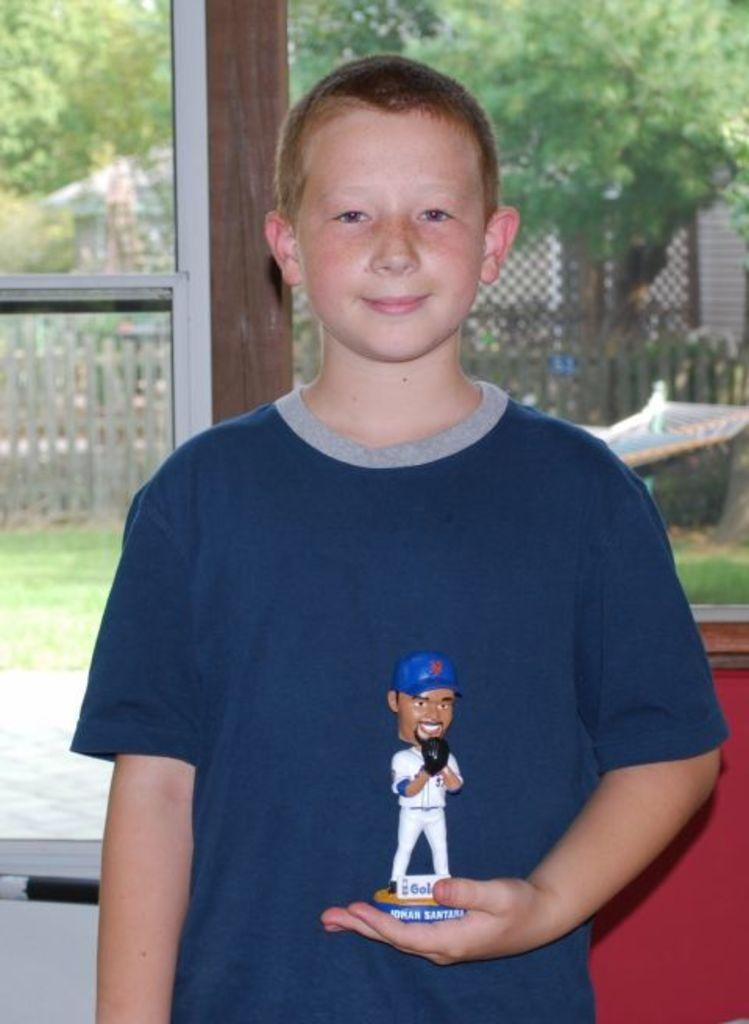Who is in the image? There is a boy in the image. What is the boy doing? The boy is standing. What is the boy holding in his hand? The boy is holding a toy in his hand. What can be seen through the window in the image? There is a window in the image, and behind it, there is a fencing visible. What is visible beyond the fencing? Trees are present behind the fencing. What type of toothpaste is the boy using in the image? There is no toothpaste present in the image; the boy is holding a toy. How does the boy's breath smell in the image? There is no information about the boy's breath in the image. 